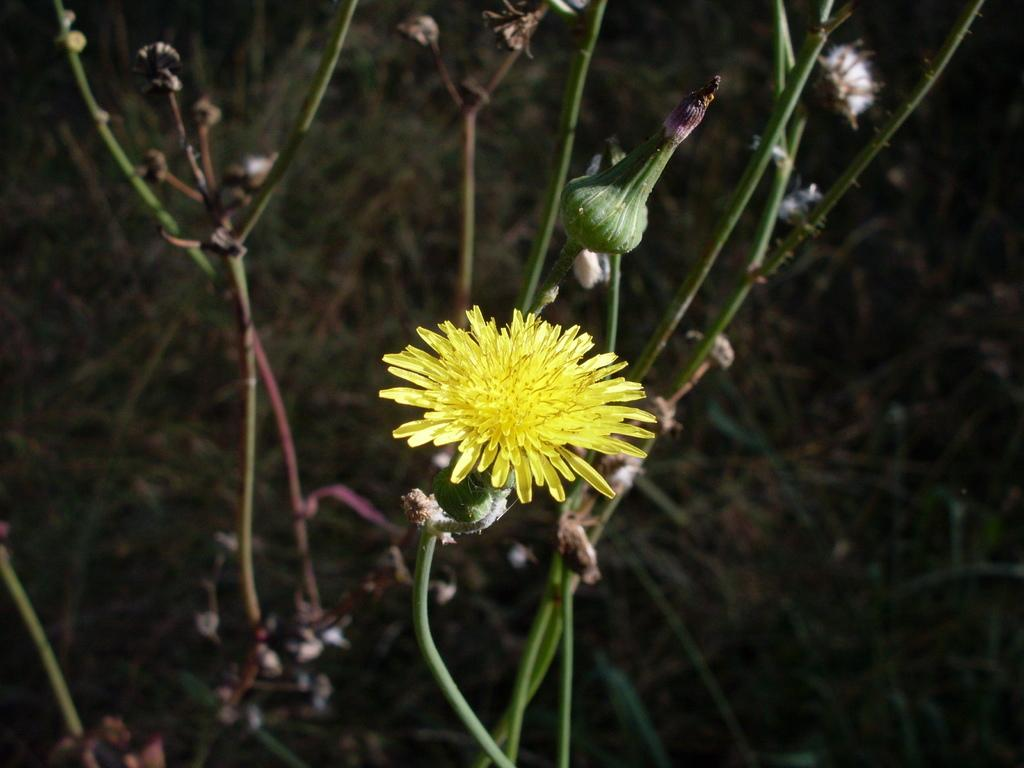What type of flower can be seen in the image? There is a yellow flower in the image. Where is the flower located? The flower is on a plant. What else can be seen in the background of the image? There are other plants in the background of the image. How many jellyfish are swimming in the image? There are no jellyfish present in the image; it features a yellow flower on a plant and other plants in the background. 